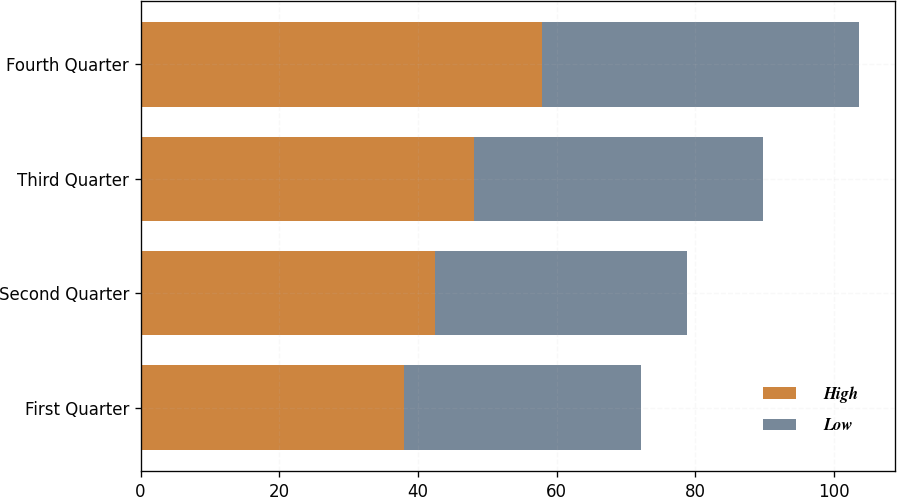<chart> <loc_0><loc_0><loc_500><loc_500><stacked_bar_chart><ecel><fcel>First Quarter<fcel>Second Quarter<fcel>Third Quarter<fcel>Fourth Quarter<nl><fcel>High<fcel>38.02<fcel>42.52<fcel>48.09<fcel>57.92<nl><fcel>Low<fcel>34.19<fcel>36.24<fcel>41.66<fcel>45.68<nl></chart> 